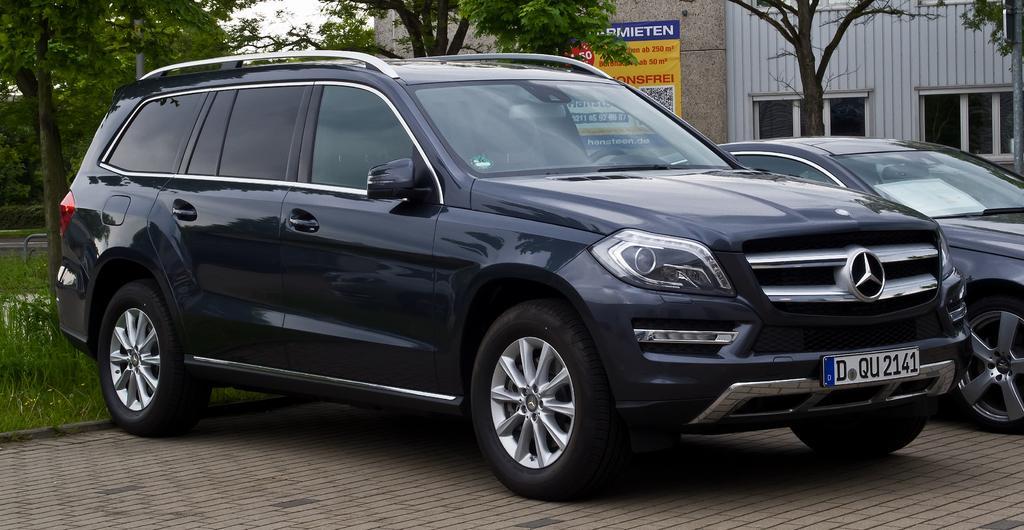In one or two sentences, can you explain what this image depicts? In this picture we can see black color car near to the grass. On the right we can see another car. In the background we can see many trees and building. Here we can see poster. On the right background there are two windows. On the top there is a sky. 